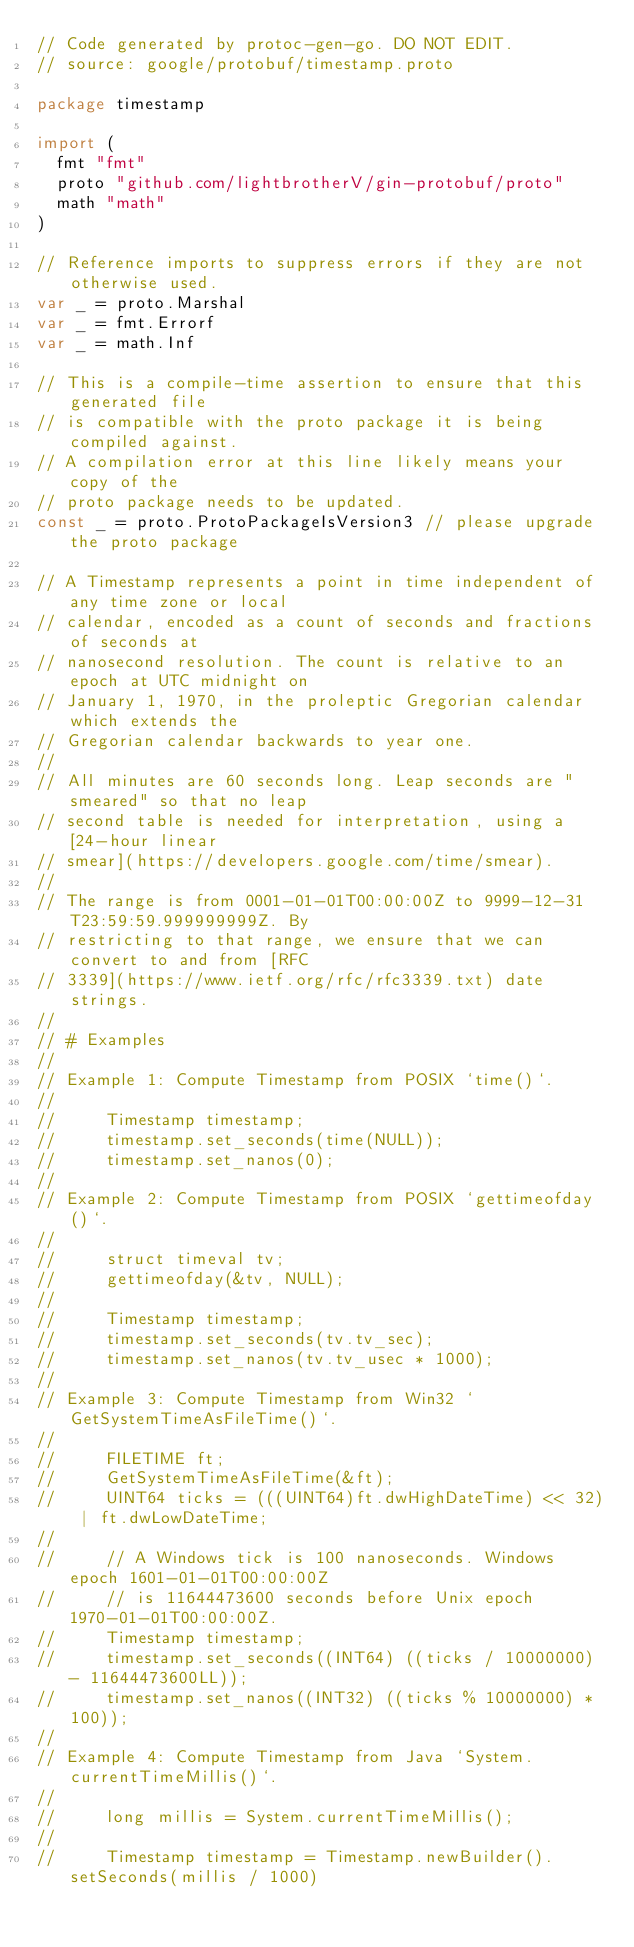Convert code to text. <code><loc_0><loc_0><loc_500><loc_500><_Go_>// Code generated by protoc-gen-go. DO NOT EDIT.
// source: google/protobuf/timestamp.proto

package timestamp

import (
	fmt "fmt"
	proto "github.com/lightbrotherV/gin-protobuf/proto"
	math "math"
)

// Reference imports to suppress errors if they are not otherwise used.
var _ = proto.Marshal
var _ = fmt.Errorf
var _ = math.Inf

// This is a compile-time assertion to ensure that this generated file
// is compatible with the proto package it is being compiled against.
// A compilation error at this line likely means your copy of the
// proto package needs to be updated.
const _ = proto.ProtoPackageIsVersion3 // please upgrade the proto package

// A Timestamp represents a point in time independent of any time zone or local
// calendar, encoded as a count of seconds and fractions of seconds at
// nanosecond resolution. The count is relative to an epoch at UTC midnight on
// January 1, 1970, in the proleptic Gregorian calendar which extends the
// Gregorian calendar backwards to year one.
//
// All minutes are 60 seconds long. Leap seconds are "smeared" so that no leap
// second table is needed for interpretation, using a [24-hour linear
// smear](https://developers.google.com/time/smear).
//
// The range is from 0001-01-01T00:00:00Z to 9999-12-31T23:59:59.999999999Z. By
// restricting to that range, we ensure that we can convert to and from [RFC
// 3339](https://www.ietf.org/rfc/rfc3339.txt) date strings.
//
// # Examples
//
// Example 1: Compute Timestamp from POSIX `time()`.
//
//     Timestamp timestamp;
//     timestamp.set_seconds(time(NULL));
//     timestamp.set_nanos(0);
//
// Example 2: Compute Timestamp from POSIX `gettimeofday()`.
//
//     struct timeval tv;
//     gettimeofday(&tv, NULL);
//
//     Timestamp timestamp;
//     timestamp.set_seconds(tv.tv_sec);
//     timestamp.set_nanos(tv.tv_usec * 1000);
//
// Example 3: Compute Timestamp from Win32 `GetSystemTimeAsFileTime()`.
//
//     FILETIME ft;
//     GetSystemTimeAsFileTime(&ft);
//     UINT64 ticks = (((UINT64)ft.dwHighDateTime) << 32) | ft.dwLowDateTime;
//
//     // A Windows tick is 100 nanoseconds. Windows epoch 1601-01-01T00:00:00Z
//     // is 11644473600 seconds before Unix epoch 1970-01-01T00:00:00Z.
//     Timestamp timestamp;
//     timestamp.set_seconds((INT64) ((ticks / 10000000) - 11644473600LL));
//     timestamp.set_nanos((INT32) ((ticks % 10000000) * 100));
//
// Example 4: Compute Timestamp from Java `System.currentTimeMillis()`.
//
//     long millis = System.currentTimeMillis();
//
//     Timestamp timestamp = Timestamp.newBuilder().setSeconds(millis / 1000)</code> 